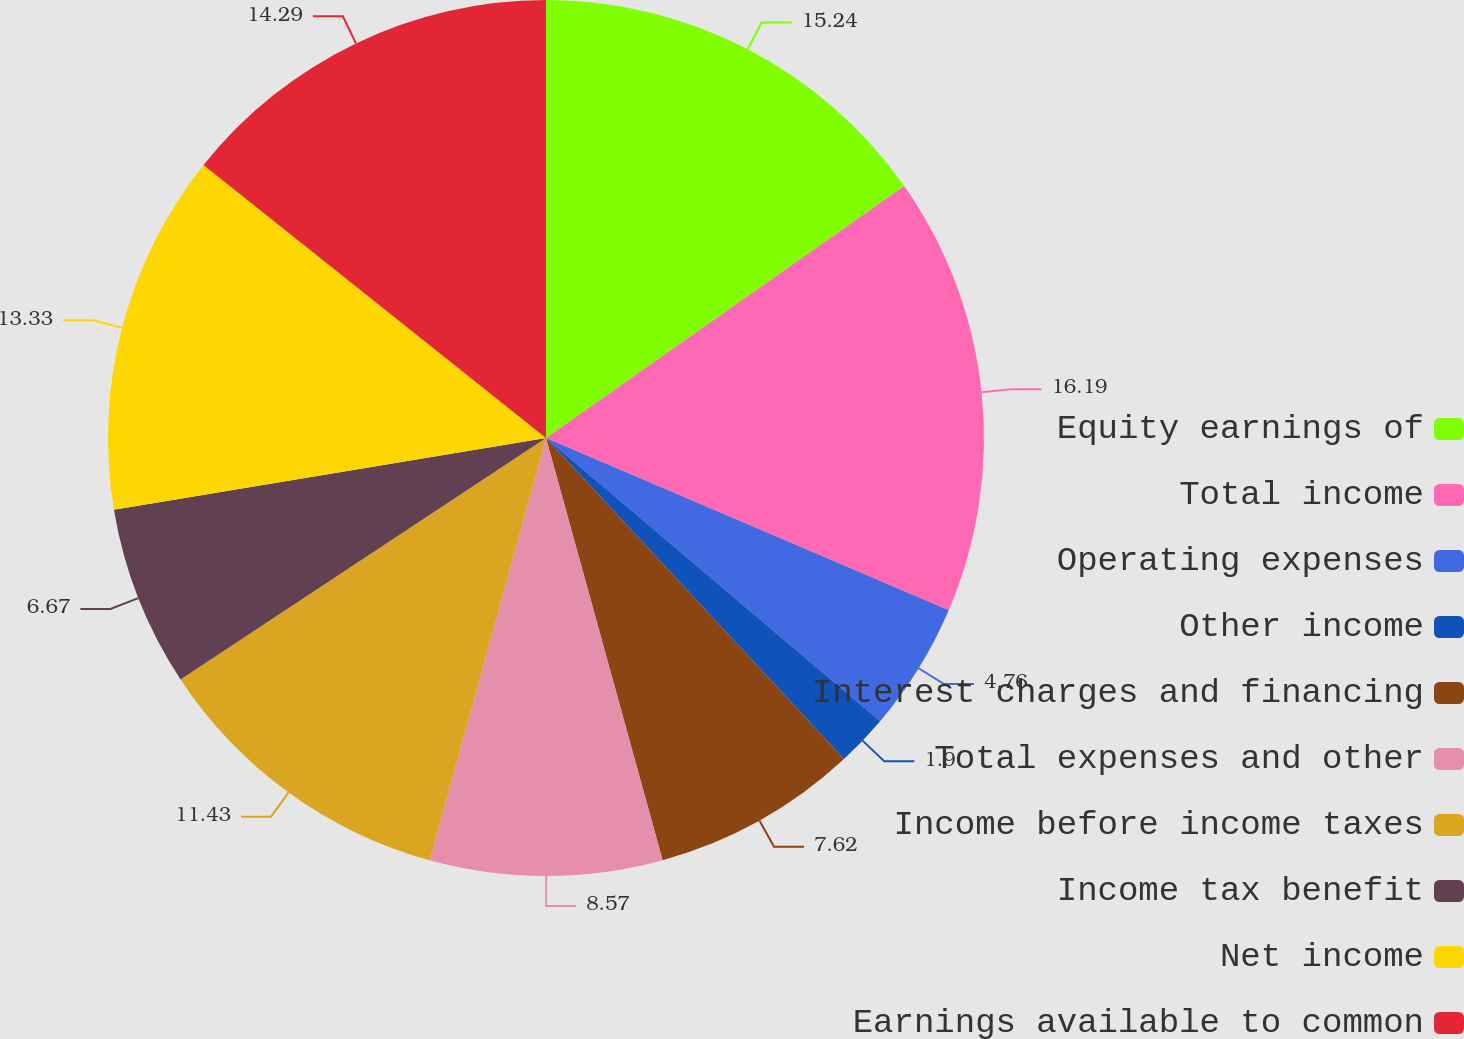<chart> <loc_0><loc_0><loc_500><loc_500><pie_chart><fcel>Equity earnings of<fcel>Total income<fcel>Operating expenses<fcel>Other income<fcel>Interest charges and financing<fcel>Total expenses and other<fcel>Income before income taxes<fcel>Income tax benefit<fcel>Net income<fcel>Earnings available to common<nl><fcel>15.24%<fcel>16.19%<fcel>4.76%<fcel>1.9%<fcel>7.62%<fcel>8.57%<fcel>11.43%<fcel>6.67%<fcel>13.33%<fcel>14.29%<nl></chart> 